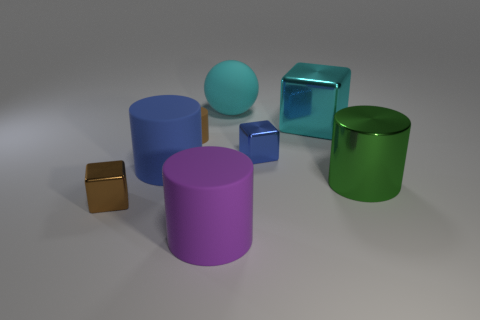Is there a yellow object of the same shape as the cyan rubber thing? no 